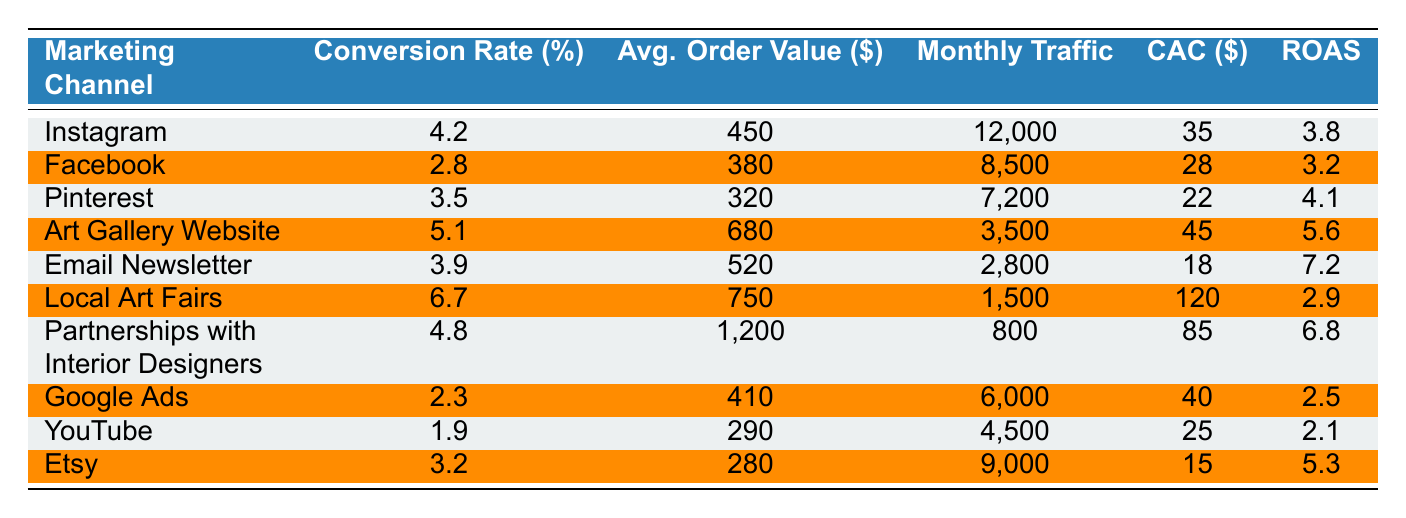What is the conversion rate for Instagram? The conversion rate for Instagram is listed directly in the table under the corresponding column. It shows 4.2%.
Answer: 4.2% Which marketing channel has the highest average order value? By comparing the average order values from the table, the highest is for "Partnerships with Interior Designers" at $1,200.
Answer: $1,200 What is the customer acquisition cost for Local Art Fairs? The customer acquisition cost for Local Art Fairs can be found in the table, which indicates $120.
Answer: $120 Which channel has the lowest conversion rate? The channel with the lowest conversion rate is Google Ads with a conversion rate of 2.3%.
Answer: Google Ads What is the average monthly traffic across all channels? To find the average monthly traffic, sum all monthly traffic values (12000 + 8500 + 7200 + 3500 + 2800 + 1500 + 800 + 6000 + 4500 + 9000 = 47700) and divide by the number of channels (10), which gives 4770.
Answer: 4770 Is the average order value for Email Newsletter higher than that for Facebook? The average order value for Email Newsletter is $520 and for Facebook is $380. Since $520 > $380, the statement is true.
Answer: Yes What is the total monthly traffic for Instagram and Art Gallery Website combined? The monthly traffic for Instagram is 12,000 and for Art Gallery Website is 3,500. Adding these (12000 + 3500) gives a total of 15,500.
Answer: 15,500 What is the return on ad spend (ROAS) for the Email Newsletter compared to the Partnerships with Interior Designers? The ROAS for Email Newsletter is 7.2 and for Partnerships with Interior Designers is 6.8. Since 7.2 > 6.8, the Email Newsletter has a higher ROAS.
Answer: Yes If we consider the channels with a conversion rate above 4%, how many are there? The channels with a conversion rate above 4% are: Instagram (4.2%), Art Gallery Website (5.1%), Local Art Fairs (6.7%), and Partnerships with Interior Designers (4.8%). This totals four channels.
Answer: 4 What is the difference in average order value between the highest and lowest channels? The highest average order value is $1,200 (Partnerships with Interior Designers) and the lowest is $280 (Etsy). The difference is $1,200 - $280 = $920.
Answer: $920 